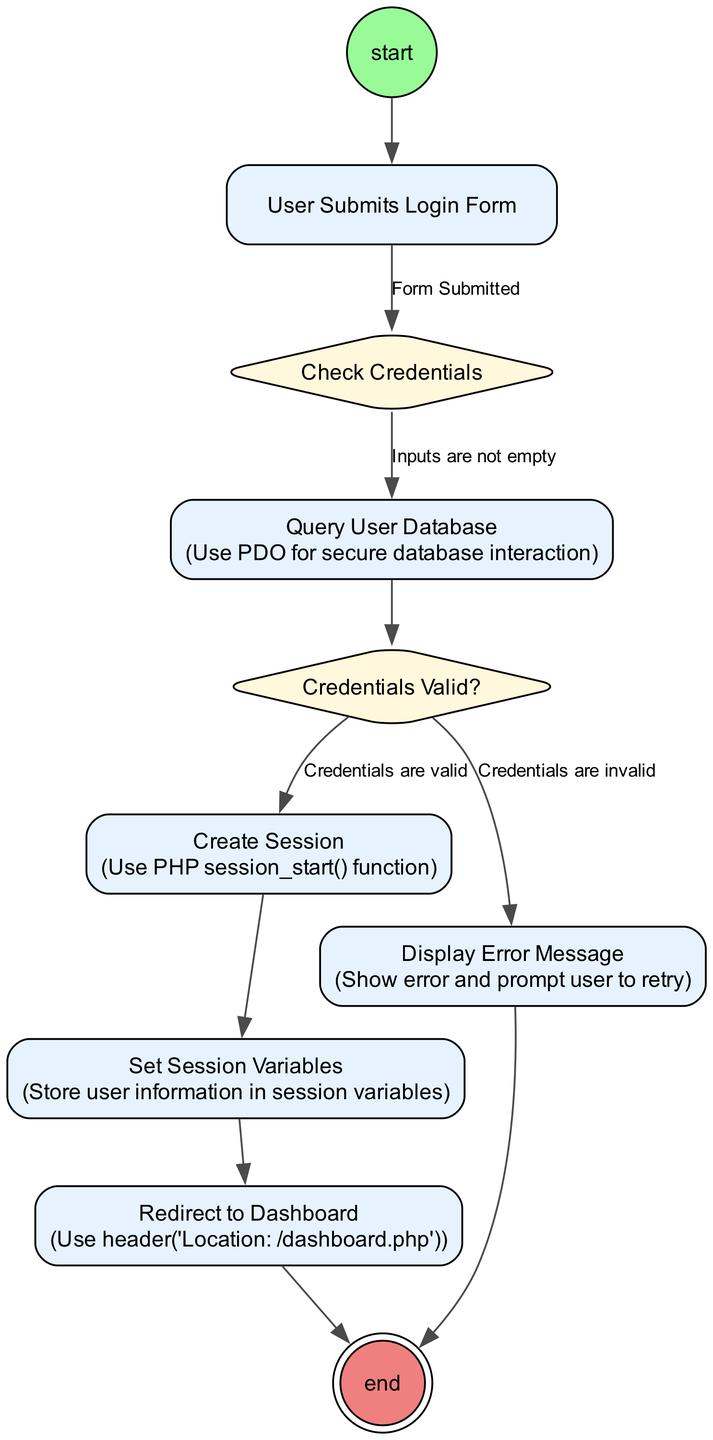What is the first action in the diagram? The initial node leads directly to the action node "User Submits Login Form," which is the first action taken in the process.
Answer: User Submits Login Form How many decision nodes are present in the diagram? There are two decision nodes: "Check Credentials" and "Credentials Valid?" This can be counted by identifying the nodes with the shape of a diamond in the diagram.
Answer: 2 What action follows the creation of a session? The action that follows "Create Session" is "Set Session Variables," which is clearly indicated in the flow from one action to the next.
Answer: Set Session Variables Under what condition does the process lead to "Display Error Message"? The flow to "Display Error Message" occurs when the guard condition "Credentials are invalid" from the decision node "Credentials Valid?" is met. This implies that if the credentials provided do not pass validation, the error message is displayed.
Answer: Credentials are invalid What does the node "Redirect to Dashboard" signify in this flow? The node "Redirect to Dashboard" signifies that after successful credential validation and session creation, the user is directed to their dashboard, indicating a successful login process.
Answer: Redirect to Dashboard What is the final outcome of the authentication process? The final node in the diagram, which is noted as "end," signifies that the authentication process has completed, either by successfully redirecting the user or displaying an error message.
Answer: end What does the edge label between "Check Credentials" and "Query User Database" indicate? The edge label "Inputs are not empty" indicates that this flow occurs only if the user inputs are validated to be non-empty before querying the user database.
Answer: Inputs are not empty What is the role of the action "Query User Database" in this process? The action "Query User Database" is crucial as it performs the operation of checking the stored user credentials against the entered values to determine their validity.
Answer: Query User Database 